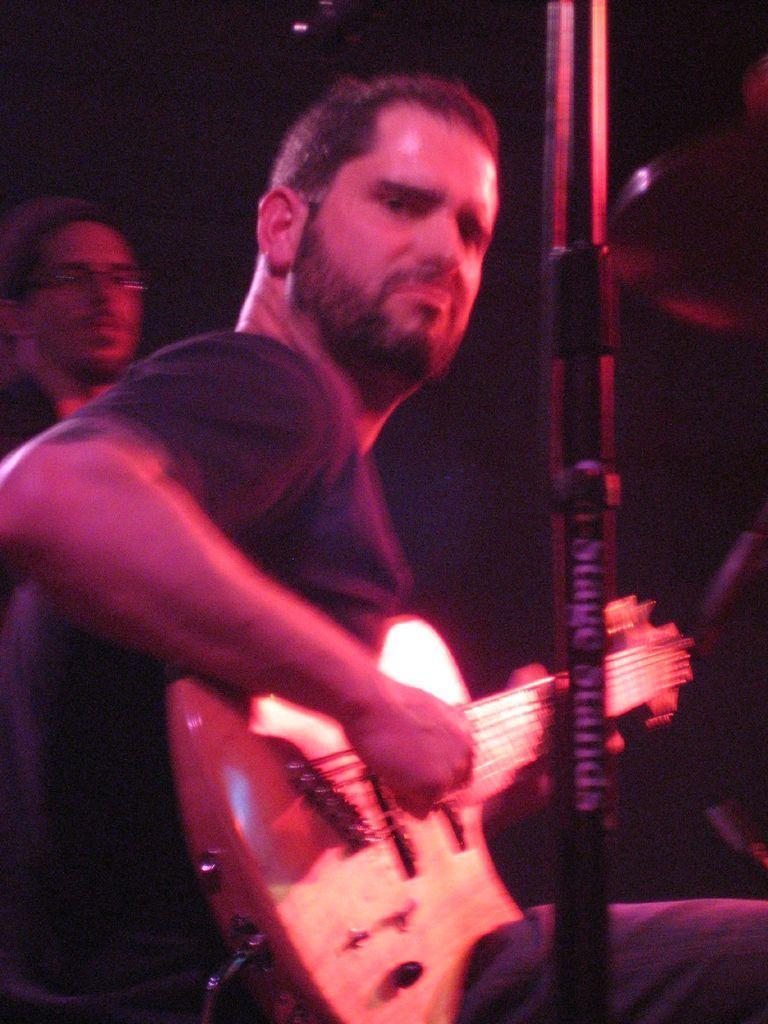Could you give a brief overview of what you see in this image? a person is sitting and playing guitar another person is standing behind. 